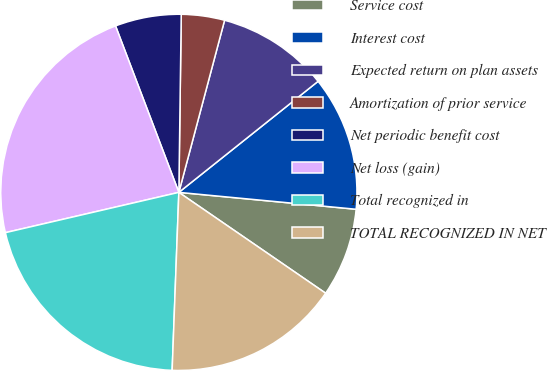<chart> <loc_0><loc_0><loc_500><loc_500><pie_chart><fcel>Service cost<fcel>Interest cost<fcel>Expected return on plan assets<fcel>Amortization of prior service<fcel>Net periodic benefit cost<fcel>Net loss (gain)<fcel>Total recognized in<fcel>TOTAL RECOGNIZED IN NET<nl><fcel>8.07%<fcel>12.23%<fcel>10.15%<fcel>3.92%<fcel>6.0%<fcel>22.85%<fcel>20.77%<fcel>16.02%<nl></chart> 